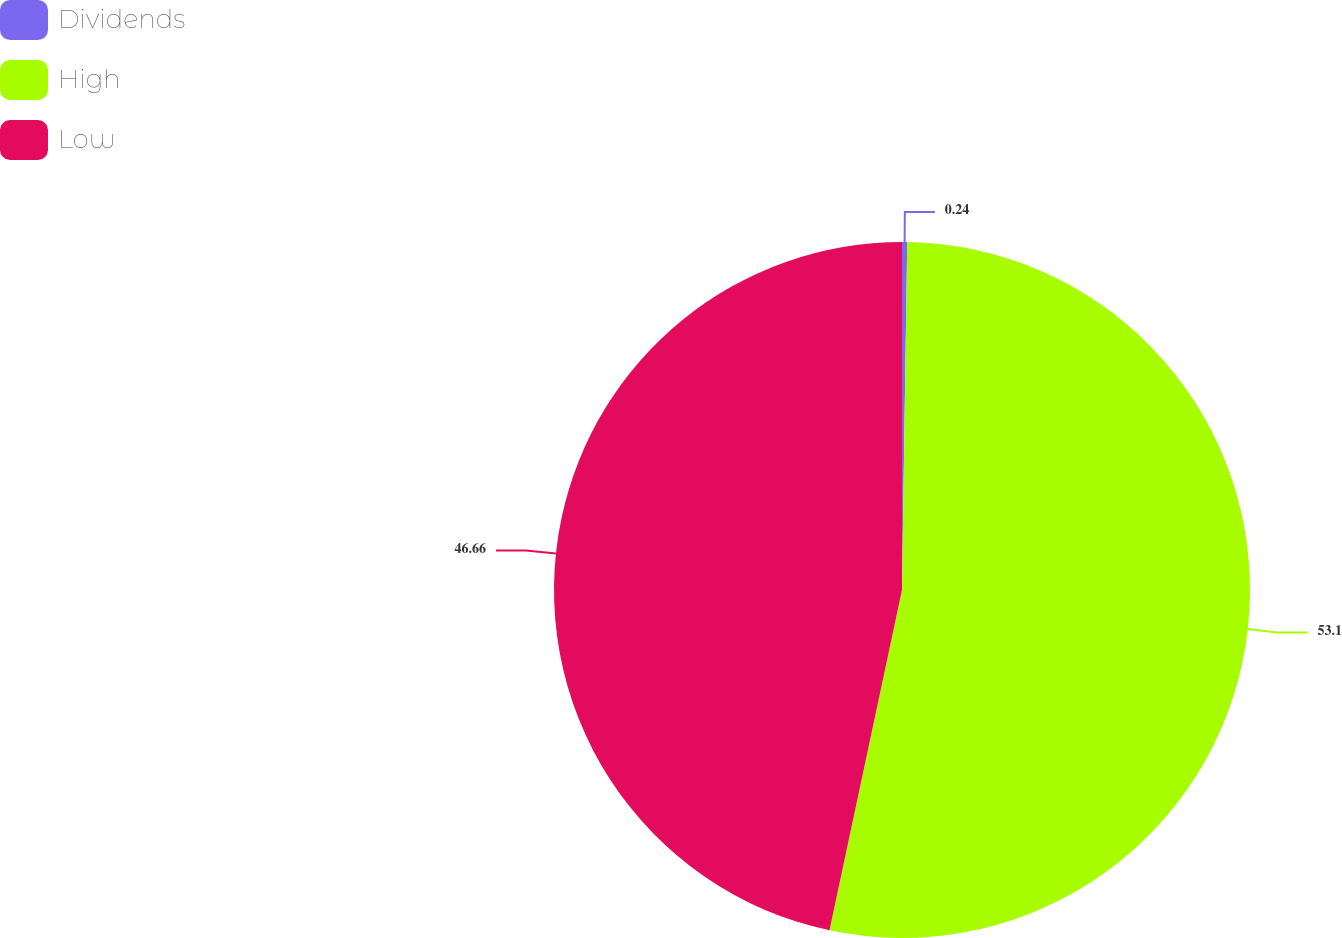Convert chart. <chart><loc_0><loc_0><loc_500><loc_500><pie_chart><fcel>Dividends<fcel>High<fcel>Low<nl><fcel>0.24%<fcel>53.1%<fcel>46.66%<nl></chart> 